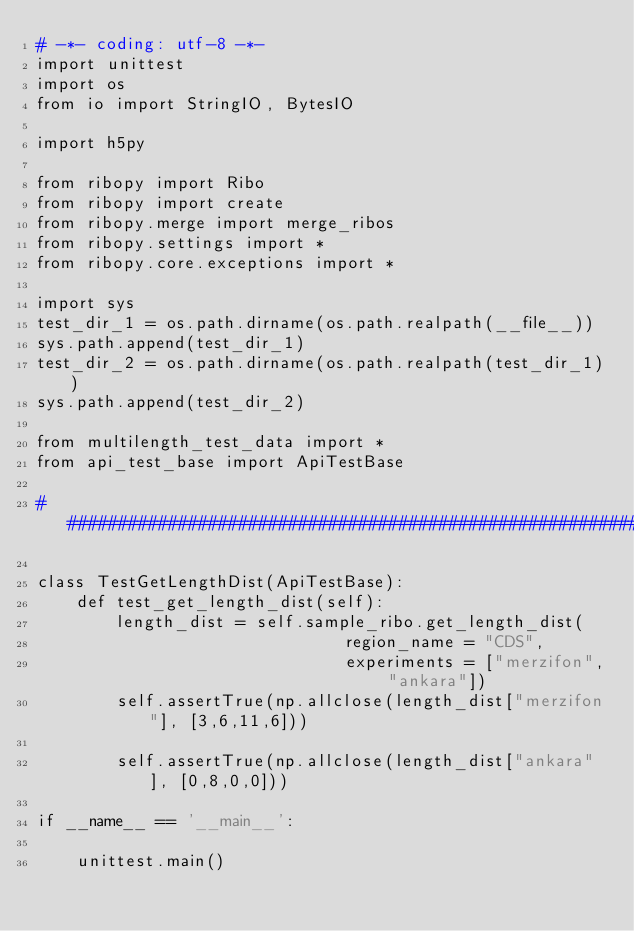Convert code to text. <code><loc_0><loc_0><loc_500><loc_500><_Python_># -*- coding: utf-8 -*-
import unittest
import os
from io import StringIO, BytesIO

import h5py

from ribopy import Ribo
from ribopy import create
from ribopy.merge import merge_ribos
from ribopy.settings import *
from ribopy.core.exceptions import *

import sys
test_dir_1 = os.path.dirname(os.path.realpath(__file__))
sys.path.append(test_dir_1)
test_dir_2 = os.path.dirname(os.path.realpath(test_dir_1))
sys.path.append(test_dir_2)

from multilength_test_data import *
from api_test_base import ApiTestBase

####################################################################

class TestGetLengthDist(ApiTestBase):
    def test_get_length_dist(self):
        length_dist = self.sample_ribo.get_length_dist(
                               region_name = "CDS",
                               experiments = ["merzifon", "ankara"])
        self.assertTrue(np.allclose(length_dist["merzifon"], [3,6,11,6]))
        
        self.assertTrue(np.allclose(length_dist["ankara"], [0,8,0,0]))
        
if __name__ == '__main__':
        
    unittest.main()
</code> 